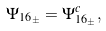Convert formula to latex. <formula><loc_0><loc_0><loc_500><loc_500>\Psi _ { { 1 6 } _ { \pm } } = \Psi _ { { 1 6 } _ { \pm } } ^ { c } ,</formula> 